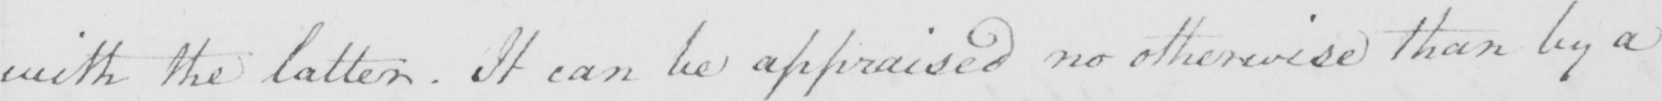Please transcribe the handwritten text in this image. with the latter . It can be appraised no otherwise than by a 